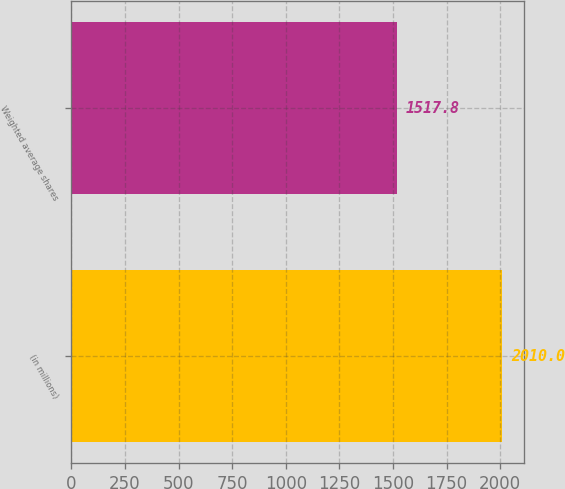<chart> <loc_0><loc_0><loc_500><loc_500><bar_chart><fcel>(in millions)<fcel>Weighted average shares<nl><fcel>2010<fcel>1517.8<nl></chart> 